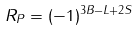<formula> <loc_0><loc_0><loc_500><loc_500>R _ { P } = ( - 1 ) ^ { 3 B - L + 2 S }</formula> 